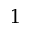Convert formula to latex. <formula><loc_0><loc_0><loc_500><loc_500>^ { 1 }</formula> 